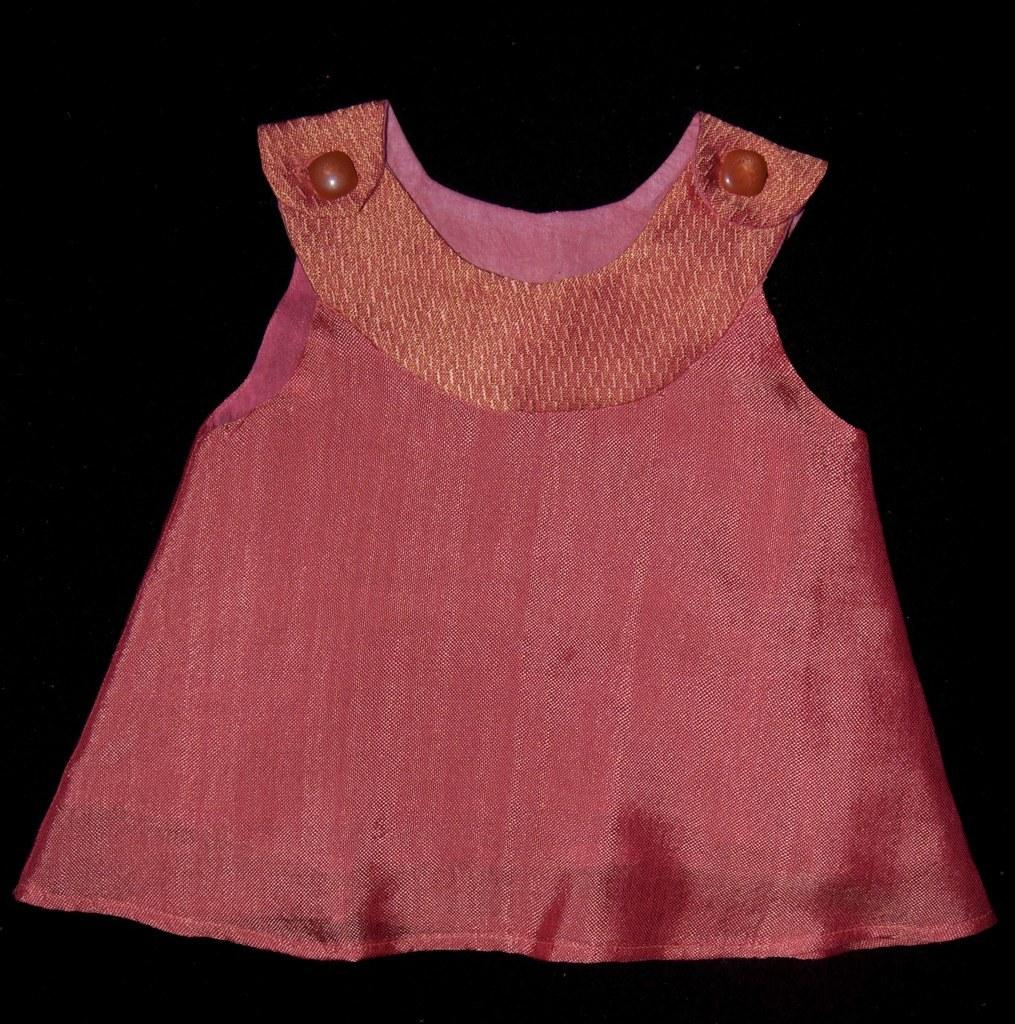What color is the frock in the image? The frock in the image is pink. How would you describe the background of the image? The background of the image is dark. How many giraffes can be seen in the image? There are no giraffes present in the image. What type of weather condition is depicted in the image? The provided facts do not mention any weather conditions, so it cannot be determined from the image. 